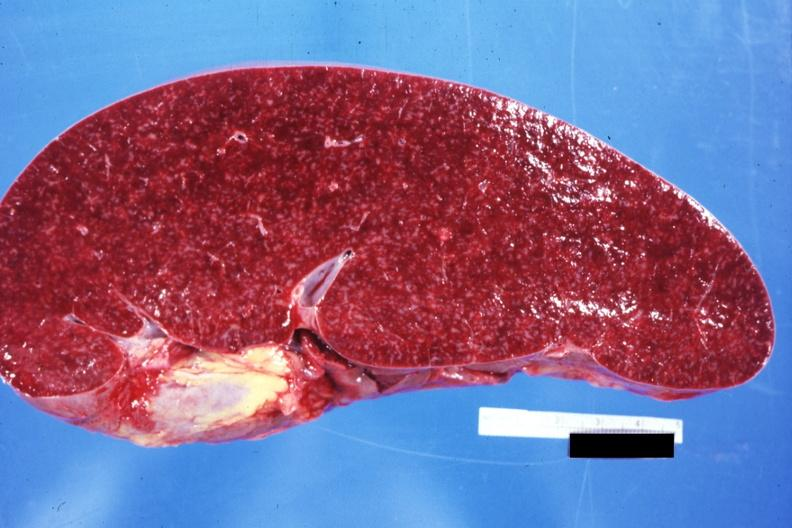what is present?
Answer the question using a single word or phrase. Spleen 